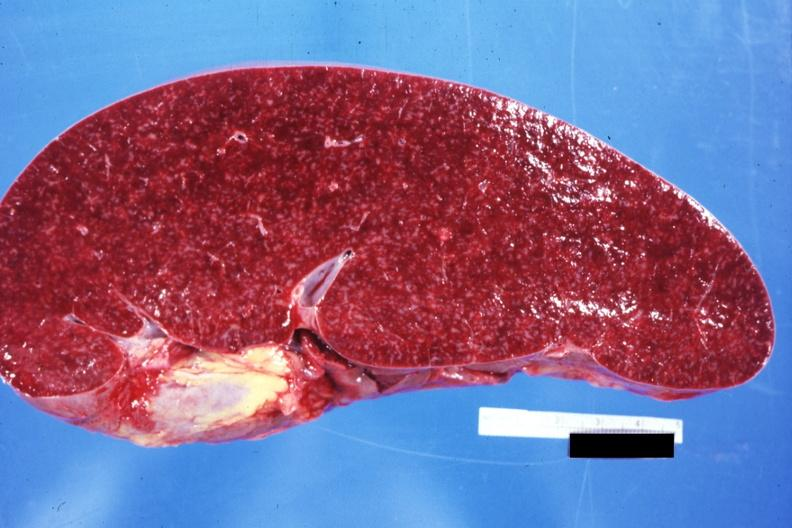what is present?
Answer the question using a single word or phrase. Spleen 